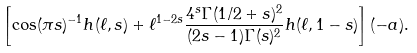<formula> <loc_0><loc_0><loc_500><loc_500>\left [ \cos ( \pi s ) ^ { - 1 } h ( \ell , s ) + \ell ^ { 1 - 2 s } \frac { 4 ^ { s } \Gamma ( 1 / 2 + s ) ^ { 2 } } { ( 2 s - 1 ) \Gamma ( s ) ^ { 2 } } h ( \ell , 1 - s ) \right ] ( - a ) .</formula> 